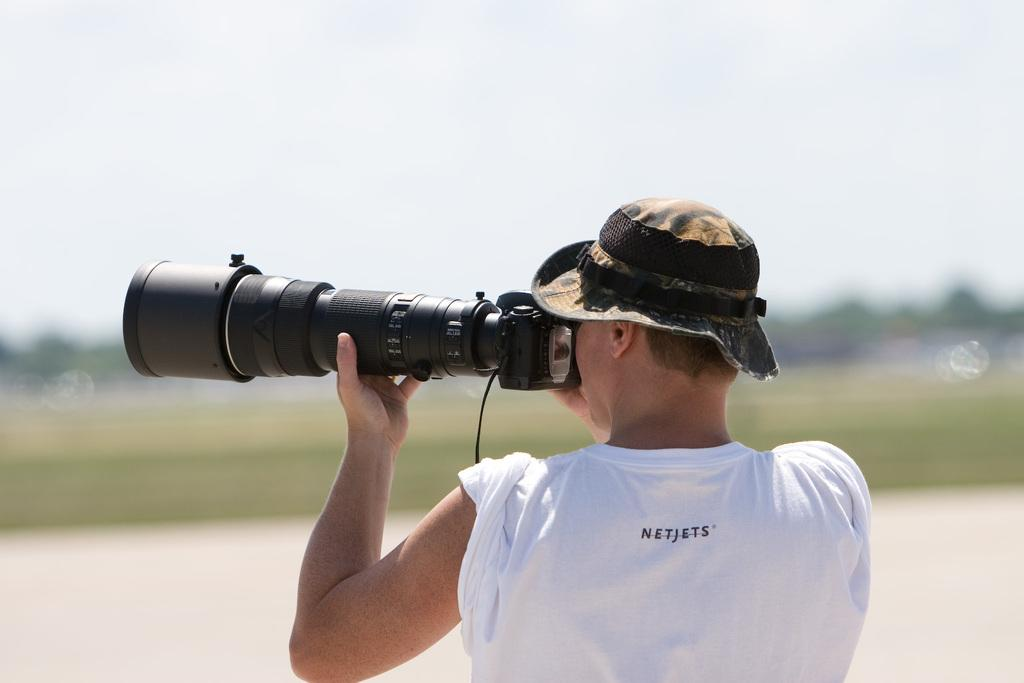What is the main subject of the image? There is a man in the image. What is the man holding in the image? The man is holding a camera. Can you see a boat in the image? There is no boat present in the image. What color is the man's eye in the image? The provided facts do not mention the color of the man's eye, so it cannot be determined from the image. 